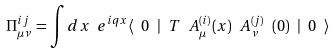<formula> <loc_0><loc_0><loc_500><loc_500>\Pi _ { \mu \nu } ^ { i j } = \int d x \ e ^ { i q x } \langle \ 0 \ | \ T \ A _ { \mu } ^ { ( i ) } ( x ) \ A _ { \nu } ^ { ( j ) } \ ( 0 ) \ | \ 0 \ \rangle</formula> 